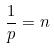Convert formula to latex. <formula><loc_0><loc_0><loc_500><loc_500>\frac { 1 } { p } = n</formula> 